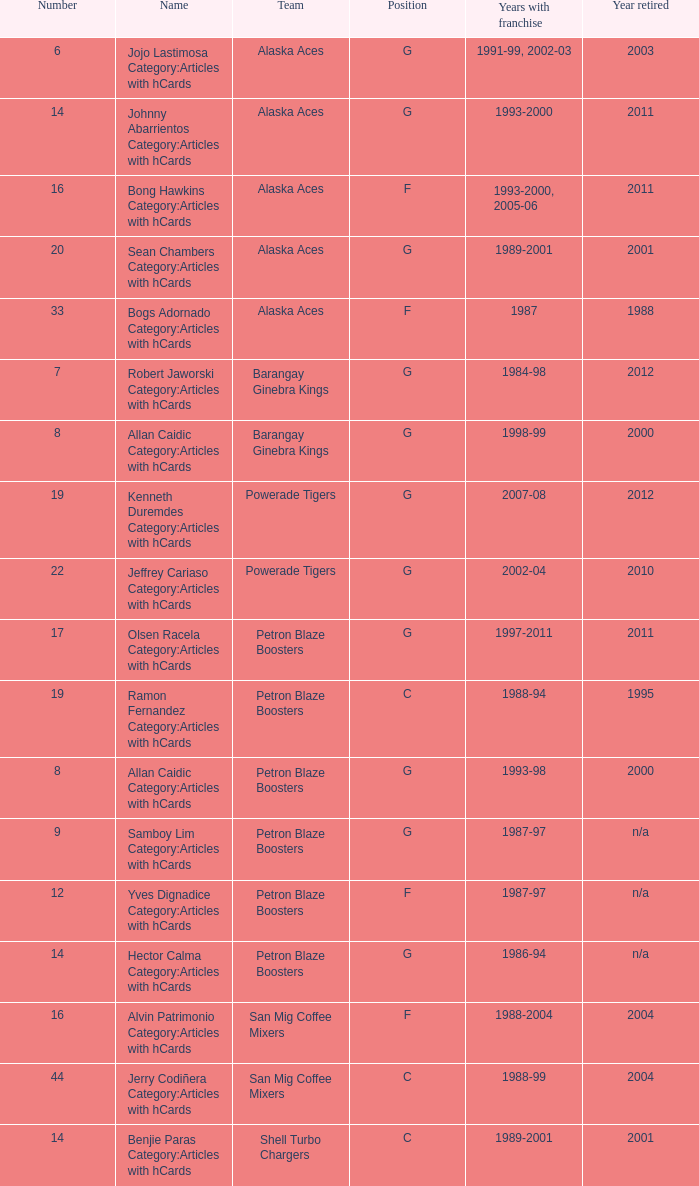Which team is number 14 and had a franchise in 1993-2000? Alaska Aces. 